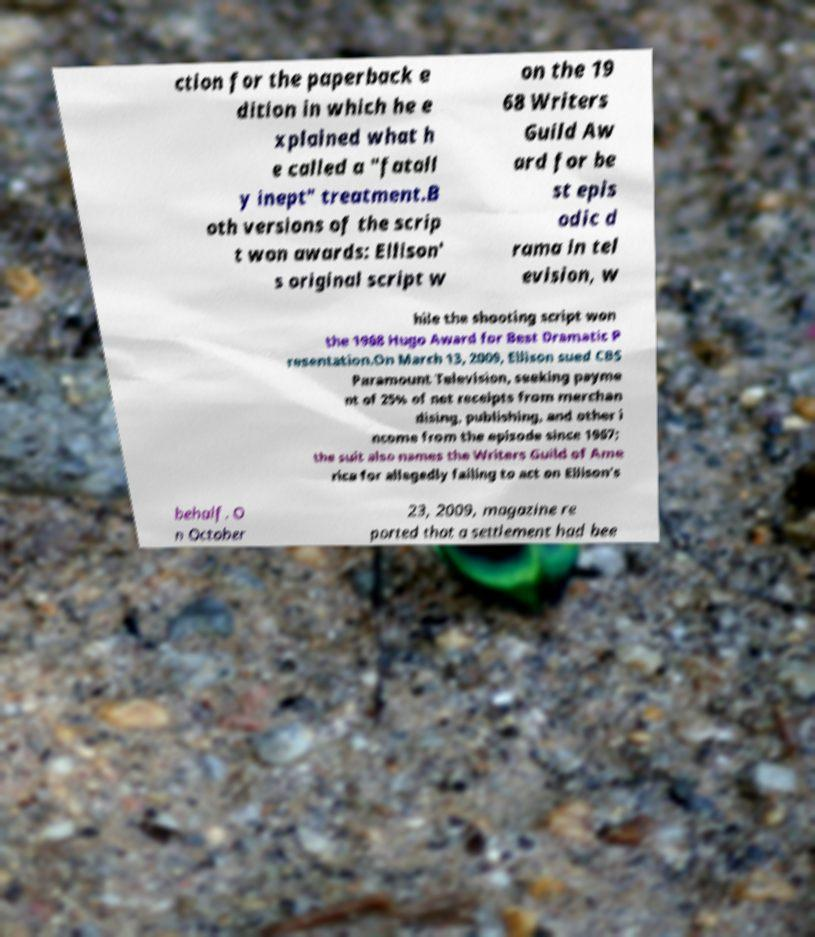What messages or text are displayed in this image? I need them in a readable, typed format. ction for the paperback e dition in which he e xplained what h e called a "fatall y inept" treatment.B oth versions of the scrip t won awards: Ellison' s original script w on the 19 68 Writers Guild Aw ard for be st epis odic d rama in tel evision, w hile the shooting script won the 1968 Hugo Award for Best Dramatic P resentation.On March 13, 2009, Ellison sued CBS Paramount Television, seeking payme nt of 25% of net receipts from merchan dising, publishing, and other i ncome from the episode since 1967; the suit also names the Writers Guild of Ame rica for allegedly failing to act on Ellison's behalf. O n October 23, 2009, magazine re ported that a settlement had bee 